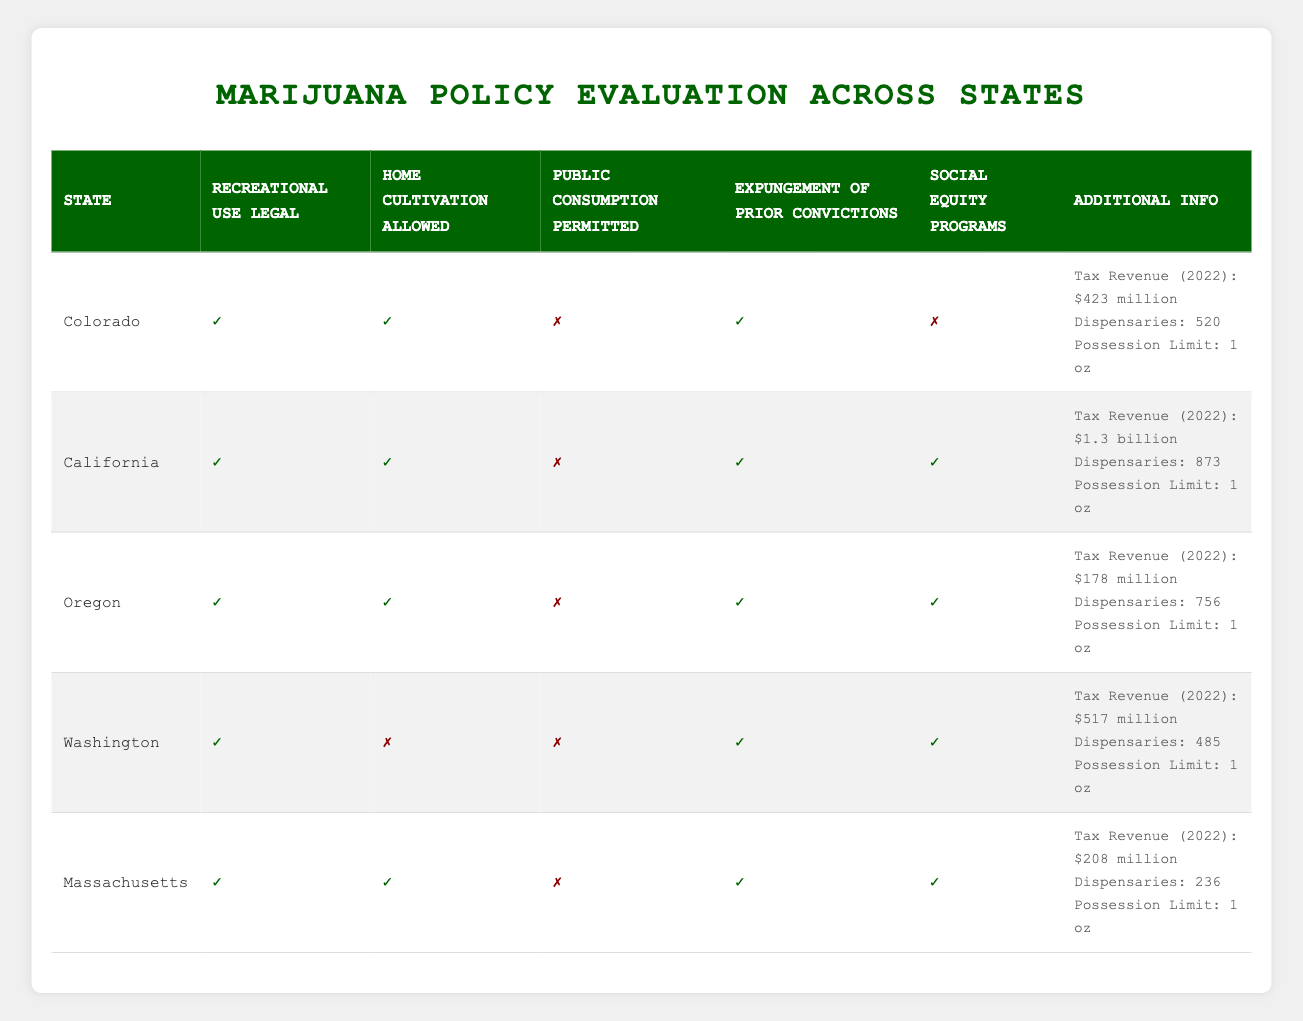What states allow home cultivation of marijuana? To find the states that allow home cultivation, we look for 'true' in the home cultivation column. Colorado, California, Oregon, and Massachusetts have 'true' listed, while Washington has 'false' for home cultivation.
Answer: Colorado, California, Oregon, Massachusetts Which state has the highest tax revenue in 2022? The tax revenues for each state are compared to identify the highest. California has a tax revenue of $1.3 billion, which is greater than Colorado ($423 million), Washington ($517 million), Oregon ($178 million), and Massachusetts ($208 million).
Answer: California Are social equity programs available in all states? By reviewing the social equity programs column, we note that California, Oregon, Washington, and Massachusetts have 'true' for social equity while Colorado is 'false'. Therefore, social equity programs are not available in all states.
Answer: No What is the total number of dispensaries across all states? We add the number of dispensaries for each state: 520 (Colorado) + 873 (California) + 756 (Oregon) + 485 (Washington) + 236 (Massachusetts) = 2870 dispensaries in total.
Answer: 2870 Is public consumption of marijuana permitted in any of the states? We check the public consumption column for 'true'. All states listed (Colorado, California, Oregon, Washington, Massachusetts) have 'false' for public consumption, indicating that it is not permitted in any of these states.
Answer: No 